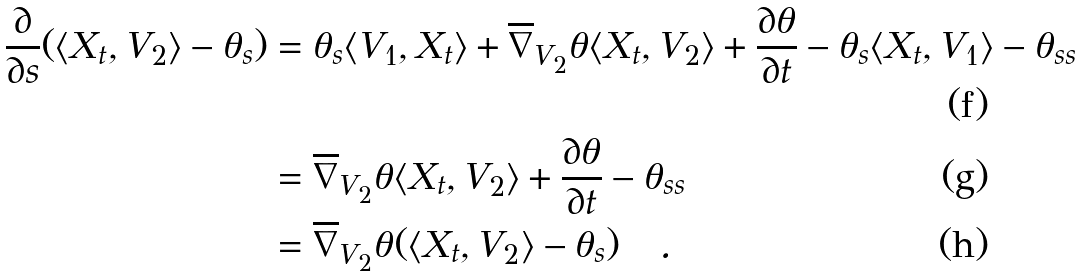<formula> <loc_0><loc_0><loc_500><loc_500>\frac { \partial } { \partial s } ( \langle X _ { t } , V _ { 2 } \rangle - \theta _ { s } ) & = \theta _ { s } \langle V _ { 1 } , X _ { t } \rangle + \overline { \nabla } _ { V _ { 2 } } \theta \langle X _ { t } , V _ { 2 } \rangle + \frac { \partial \theta } { \partial t } - \theta _ { s } \langle X _ { t } , V _ { 1 } \rangle - \theta _ { s s } \\ & = \overline { \nabla } _ { V _ { 2 } } \theta \langle X _ { t } , V _ { 2 } \rangle + \frac { \partial \theta } { \partial t } - \theta _ { s s } \\ & = \overline { \nabla } _ { V _ { 2 } } \theta ( \langle X _ { t } , V _ { 2 } \rangle - \theta _ { s } ) \quad .</formula> 